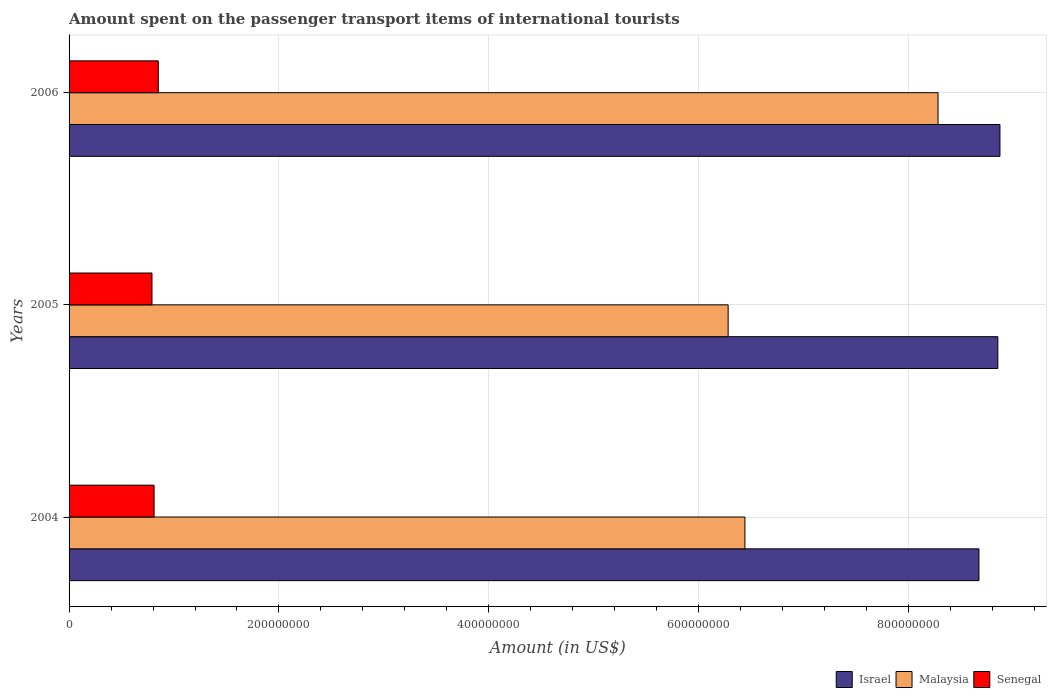How many different coloured bars are there?
Offer a very short reply. 3. How many groups of bars are there?
Provide a short and direct response. 3. Are the number of bars per tick equal to the number of legend labels?
Keep it short and to the point. Yes. Are the number of bars on each tick of the Y-axis equal?
Make the answer very short. Yes. How many bars are there on the 2nd tick from the top?
Your answer should be very brief. 3. What is the label of the 2nd group of bars from the top?
Offer a very short reply. 2005. In how many cases, is the number of bars for a given year not equal to the number of legend labels?
Offer a very short reply. 0. What is the amount spent on the passenger transport items of international tourists in Malaysia in 2004?
Keep it short and to the point. 6.44e+08. Across all years, what is the maximum amount spent on the passenger transport items of international tourists in Malaysia?
Provide a succinct answer. 8.28e+08. Across all years, what is the minimum amount spent on the passenger transport items of international tourists in Malaysia?
Provide a succinct answer. 6.28e+08. What is the total amount spent on the passenger transport items of international tourists in Senegal in the graph?
Make the answer very short. 2.45e+08. What is the difference between the amount spent on the passenger transport items of international tourists in Israel in 2005 and that in 2006?
Provide a short and direct response. -2.00e+06. What is the difference between the amount spent on the passenger transport items of international tourists in Israel in 2006 and the amount spent on the passenger transport items of international tourists in Malaysia in 2005?
Provide a succinct answer. 2.59e+08. What is the average amount spent on the passenger transport items of international tourists in Malaysia per year?
Your answer should be compact. 7.00e+08. In the year 2004, what is the difference between the amount spent on the passenger transport items of international tourists in Israel and amount spent on the passenger transport items of international tourists in Senegal?
Offer a very short reply. 7.86e+08. In how many years, is the amount spent on the passenger transport items of international tourists in Senegal greater than 520000000 US$?
Make the answer very short. 0. What is the ratio of the amount spent on the passenger transport items of international tourists in Malaysia in 2004 to that in 2005?
Provide a succinct answer. 1.03. Is the difference between the amount spent on the passenger transport items of international tourists in Israel in 2005 and 2006 greater than the difference between the amount spent on the passenger transport items of international tourists in Senegal in 2005 and 2006?
Offer a terse response. Yes. What is the difference between the highest and the second highest amount spent on the passenger transport items of international tourists in Malaysia?
Provide a short and direct response. 1.84e+08. Is the sum of the amount spent on the passenger transport items of international tourists in Israel in 2004 and 2006 greater than the maximum amount spent on the passenger transport items of international tourists in Senegal across all years?
Give a very brief answer. Yes. What does the 1st bar from the top in 2005 represents?
Offer a terse response. Senegal. Is it the case that in every year, the sum of the amount spent on the passenger transport items of international tourists in Malaysia and amount spent on the passenger transport items of international tourists in Senegal is greater than the amount spent on the passenger transport items of international tourists in Israel?
Your answer should be very brief. No. Are all the bars in the graph horizontal?
Make the answer very short. Yes. How many years are there in the graph?
Your answer should be compact. 3. Are the values on the major ticks of X-axis written in scientific E-notation?
Your response must be concise. No. Does the graph contain any zero values?
Keep it short and to the point. No. Does the graph contain grids?
Offer a very short reply. Yes. Where does the legend appear in the graph?
Provide a short and direct response. Bottom right. How many legend labels are there?
Your response must be concise. 3. How are the legend labels stacked?
Offer a very short reply. Horizontal. What is the title of the graph?
Your answer should be very brief. Amount spent on the passenger transport items of international tourists. What is the label or title of the X-axis?
Provide a succinct answer. Amount (in US$). What is the Amount (in US$) in Israel in 2004?
Provide a short and direct response. 8.67e+08. What is the Amount (in US$) in Malaysia in 2004?
Keep it short and to the point. 6.44e+08. What is the Amount (in US$) of Senegal in 2004?
Make the answer very short. 8.10e+07. What is the Amount (in US$) of Israel in 2005?
Provide a short and direct response. 8.85e+08. What is the Amount (in US$) in Malaysia in 2005?
Your answer should be very brief. 6.28e+08. What is the Amount (in US$) in Senegal in 2005?
Provide a succinct answer. 7.90e+07. What is the Amount (in US$) of Israel in 2006?
Offer a very short reply. 8.87e+08. What is the Amount (in US$) of Malaysia in 2006?
Provide a short and direct response. 8.28e+08. What is the Amount (in US$) in Senegal in 2006?
Your answer should be compact. 8.50e+07. Across all years, what is the maximum Amount (in US$) in Israel?
Offer a very short reply. 8.87e+08. Across all years, what is the maximum Amount (in US$) of Malaysia?
Your answer should be very brief. 8.28e+08. Across all years, what is the maximum Amount (in US$) of Senegal?
Give a very brief answer. 8.50e+07. Across all years, what is the minimum Amount (in US$) of Israel?
Your response must be concise. 8.67e+08. Across all years, what is the minimum Amount (in US$) in Malaysia?
Keep it short and to the point. 6.28e+08. Across all years, what is the minimum Amount (in US$) in Senegal?
Offer a very short reply. 7.90e+07. What is the total Amount (in US$) of Israel in the graph?
Offer a very short reply. 2.64e+09. What is the total Amount (in US$) in Malaysia in the graph?
Your answer should be very brief. 2.10e+09. What is the total Amount (in US$) in Senegal in the graph?
Provide a succinct answer. 2.45e+08. What is the difference between the Amount (in US$) in Israel in 2004 and that in 2005?
Keep it short and to the point. -1.80e+07. What is the difference between the Amount (in US$) of Malaysia in 2004 and that in 2005?
Provide a short and direct response. 1.60e+07. What is the difference between the Amount (in US$) of Israel in 2004 and that in 2006?
Your answer should be compact. -2.00e+07. What is the difference between the Amount (in US$) in Malaysia in 2004 and that in 2006?
Ensure brevity in your answer.  -1.84e+08. What is the difference between the Amount (in US$) in Senegal in 2004 and that in 2006?
Your response must be concise. -4.00e+06. What is the difference between the Amount (in US$) of Malaysia in 2005 and that in 2006?
Your response must be concise. -2.00e+08. What is the difference between the Amount (in US$) in Senegal in 2005 and that in 2006?
Keep it short and to the point. -6.00e+06. What is the difference between the Amount (in US$) in Israel in 2004 and the Amount (in US$) in Malaysia in 2005?
Offer a very short reply. 2.39e+08. What is the difference between the Amount (in US$) of Israel in 2004 and the Amount (in US$) of Senegal in 2005?
Offer a very short reply. 7.88e+08. What is the difference between the Amount (in US$) in Malaysia in 2004 and the Amount (in US$) in Senegal in 2005?
Provide a short and direct response. 5.65e+08. What is the difference between the Amount (in US$) in Israel in 2004 and the Amount (in US$) in Malaysia in 2006?
Ensure brevity in your answer.  3.90e+07. What is the difference between the Amount (in US$) in Israel in 2004 and the Amount (in US$) in Senegal in 2006?
Offer a very short reply. 7.82e+08. What is the difference between the Amount (in US$) in Malaysia in 2004 and the Amount (in US$) in Senegal in 2006?
Keep it short and to the point. 5.59e+08. What is the difference between the Amount (in US$) in Israel in 2005 and the Amount (in US$) in Malaysia in 2006?
Your answer should be compact. 5.70e+07. What is the difference between the Amount (in US$) in Israel in 2005 and the Amount (in US$) in Senegal in 2006?
Make the answer very short. 8.00e+08. What is the difference between the Amount (in US$) in Malaysia in 2005 and the Amount (in US$) in Senegal in 2006?
Your answer should be compact. 5.43e+08. What is the average Amount (in US$) in Israel per year?
Provide a succinct answer. 8.80e+08. What is the average Amount (in US$) in Malaysia per year?
Your answer should be very brief. 7.00e+08. What is the average Amount (in US$) in Senegal per year?
Keep it short and to the point. 8.17e+07. In the year 2004, what is the difference between the Amount (in US$) of Israel and Amount (in US$) of Malaysia?
Your response must be concise. 2.23e+08. In the year 2004, what is the difference between the Amount (in US$) of Israel and Amount (in US$) of Senegal?
Give a very brief answer. 7.86e+08. In the year 2004, what is the difference between the Amount (in US$) of Malaysia and Amount (in US$) of Senegal?
Your response must be concise. 5.63e+08. In the year 2005, what is the difference between the Amount (in US$) of Israel and Amount (in US$) of Malaysia?
Offer a terse response. 2.57e+08. In the year 2005, what is the difference between the Amount (in US$) in Israel and Amount (in US$) in Senegal?
Keep it short and to the point. 8.06e+08. In the year 2005, what is the difference between the Amount (in US$) of Malaysia and Amount (in US$) of Senegal?
Give a very brief answer. 5.49e+08. In the year 2006, what is the difference between the Amount (in US$) of Israel and Amount (in US$) of Malaysia?
Ensure brevity in your answer.  5.90e+07. In the year 2006, what is the difference between the Amount (in US$) of Israel and Amount (in US$) of Senegal?
Your answer should be compact. 8.02e+08. In the year 2006, what is the difference between the Amount (in US$) of Malaysia and Amount (in US$) of Senegal?
Ensure brevity in your answer.  7.43e+08. What is the ratio of the Amount (in US$) in Israel in 2004 to that in 2005?
Provide a short and direct response. 0.98. What is the ratio of the Amount (in US$) in Malaysia in 2004 to that in 2005?
Ensure brevity in your answer.  1.03. What is the ratio of the Amount (in US$) in Senegal in 2004 to that in 2005?
Keep it short and to the point. 1.03. What is the ratio of the Amount (in US$) in Israel in 2004 to that in 2006?
Offer a very short reply. 0.98. What is the ratio of the Amount (in US$) of Malaysia in 2004 to that in 2006?
Offer a terse response. 0.78. What is the ratio of the Amount (in US$) in Senegal in 2004 to that in 2006?
Keep it short and to the point. 0.95. What is the ratio of the Amount (in US$) of Israel in 2005 to that in 2006?
Ensure brevity in your answer.  1. What is the ratio of the Amount (in US$) in Malaysia in 2005 to that in 2006?
Ensure brevity in your answer.  0.76. What is the ratio of the Amount (in US$) in Senegal in 2005 to that in 2006?
Ensure brevity in your answer.  0.93. What is the difference between the highest and the second highest Amount (in US$) in Malaysia?
Offer a very short reply. 1.84e+08. What is the difference between the highest and the lowest Amount (in US$) of Malaysia?
Your answer should be compact. 2.00e+08. What is the difference between the highest and the lowest Amount (in US$) in Senegal?
Keep it short and to the point. 6.00e+06. 